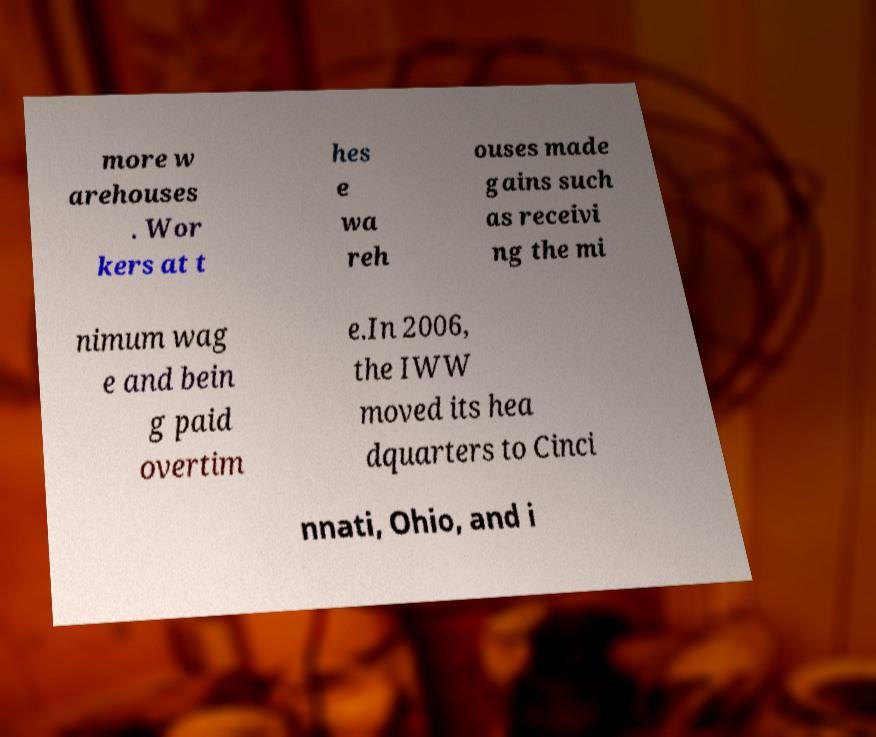What messages or text are displayed in this image? I need them in a readable, typed format. more w arehouses . Wor kers at t hes e wa reh ouses made gains such as receivi ng the mi nimum wag e and bein g paid overtim e.In 2006, the IWW moved its hea dquarters to Cinci nnati, Ohio, and i 